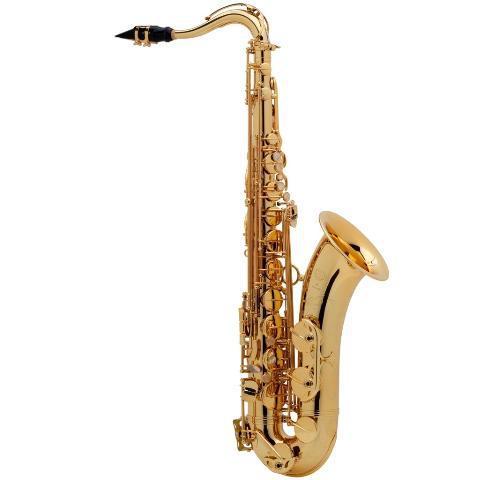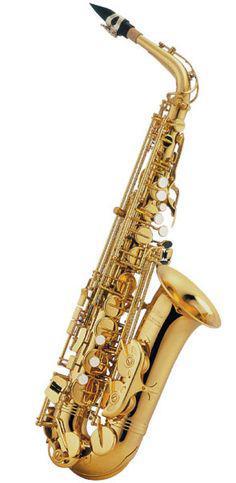The first image is the image on the left, the second image is the image on the right. Considering the images on both sides, is "The saxophone on the left is standing straight up and down." valid? Answer yes or no. Yes. 